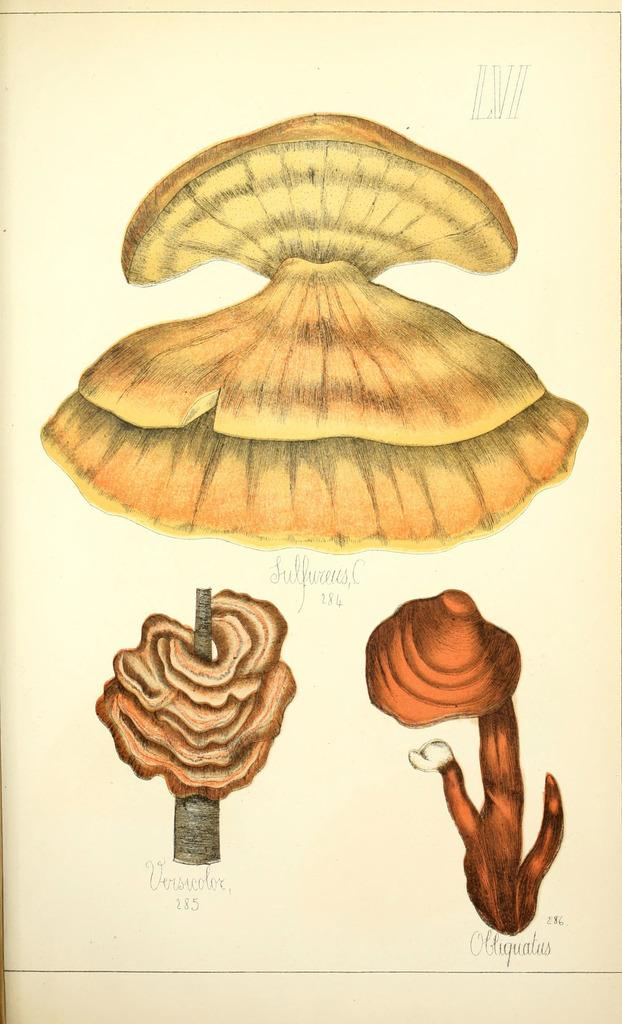What is depicted on the paper in the image? There are pictures printed on a paper in the image. How many flowers are present in the image? There are no flowers present in the image; it only features pictures printed on a paper. What type of ghost can be seen interacting with the pictures in the image? There is no ghost present in the image; it only features pictures printed on a paper. 